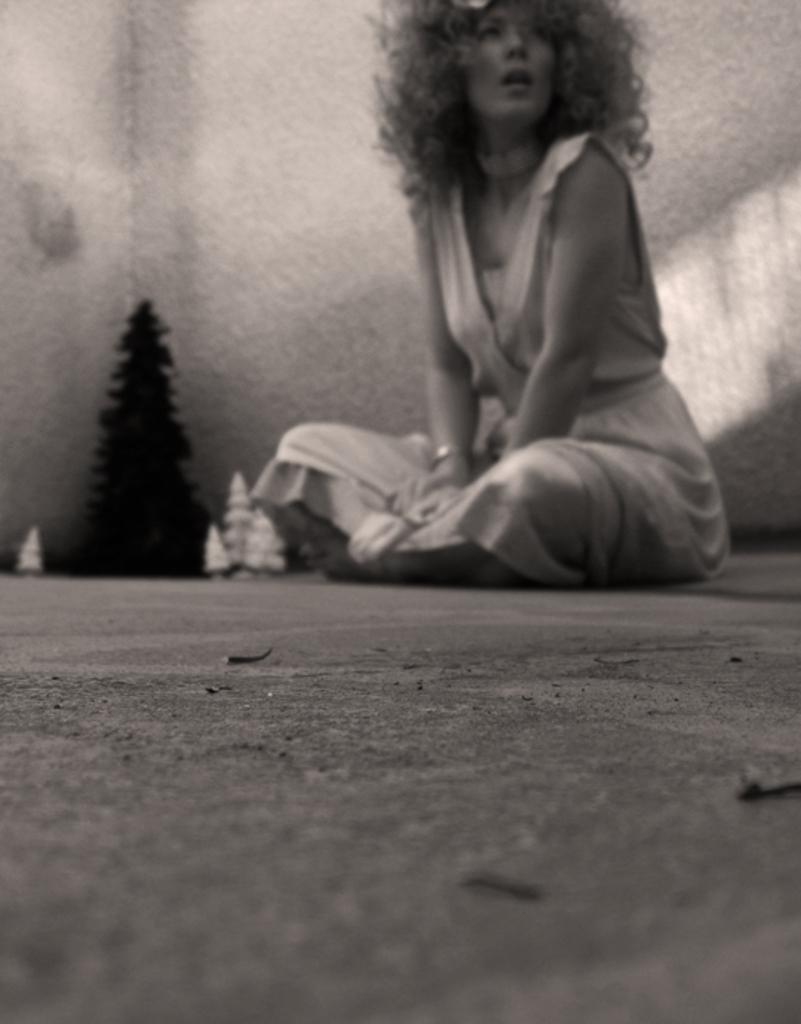Describe this image in one or two sentences. In this image I can see a woman sitting on floor and back side of her I can see the wall, in front of the wall it might be toy trees. 